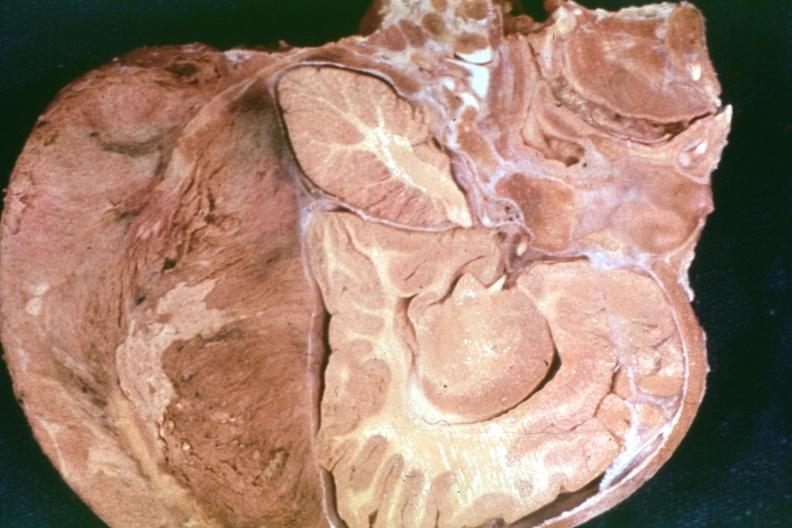s metastatic neuroblastoma present?
Answer the question using a single word or phrase. Yes 